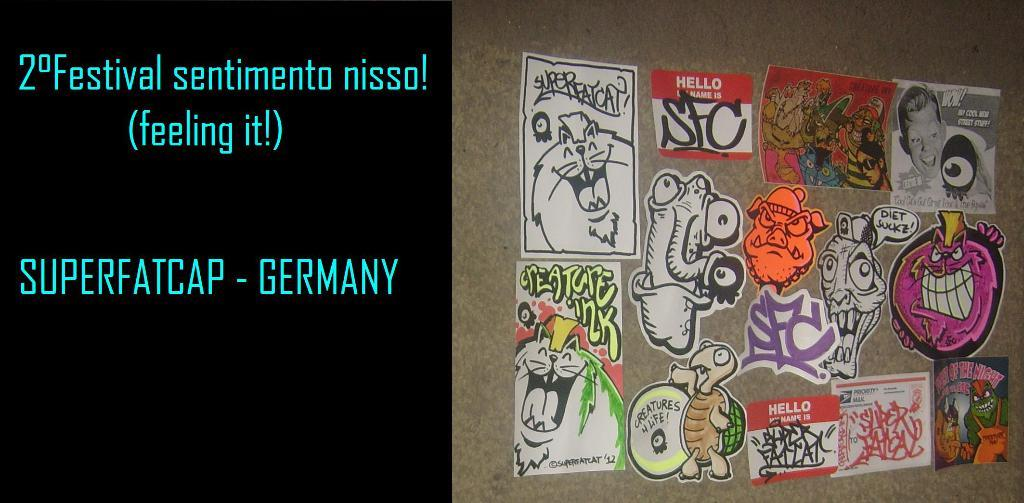What is located on the right side of the image? There is a wall on the right side of the image. What is on the wall in the image? There are stickers on the wall. What can be seen on the left side of the image? There is some text visible on the left side of the image. What type of music can be heard playing in the background of the image? There is no music or audio present in the image, so it is not possible to determine what, if any, music might be heard. 